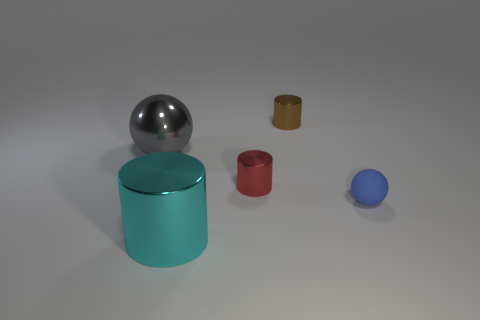How many metal objects are small green balls or red cylinders?
Keep it short and to the point. 1. What color is the other matte object that is the same shape as the large gray object?
Provide a short and direct response. Blue. What number of objects are brown metal things or brown rubber cubes?
Keep it short and to the point. 1. What shape is the brown thing that is made of the same material as the large gray sphere?
Your answer should be very brief. Cylinder. How many tiny things are blue objects or brown cylinders?
Make the answer very short. 2. What number of metal cylinders are to the left of the small object that is to the right of the tiny cylinder behind the red shiny object?
Offer a very short reply. 3. There is a metal thing that is on the left side of the cyan metal cylinder; does it have the same size as the tiny red thing?
Your response must be concise. No. Are there fewer tiny objects in front of the large shiny cylinder than brown things that are in front of the red cylinder?
Your answer should be very brief. No. Does the matte ball have the same color as the shiny sphere?
Make the answer very short. No. Are there fewer gray objects that are behind the gray metallic ball than tiny brown metallic objects?
Offer a terse response. Yes. 